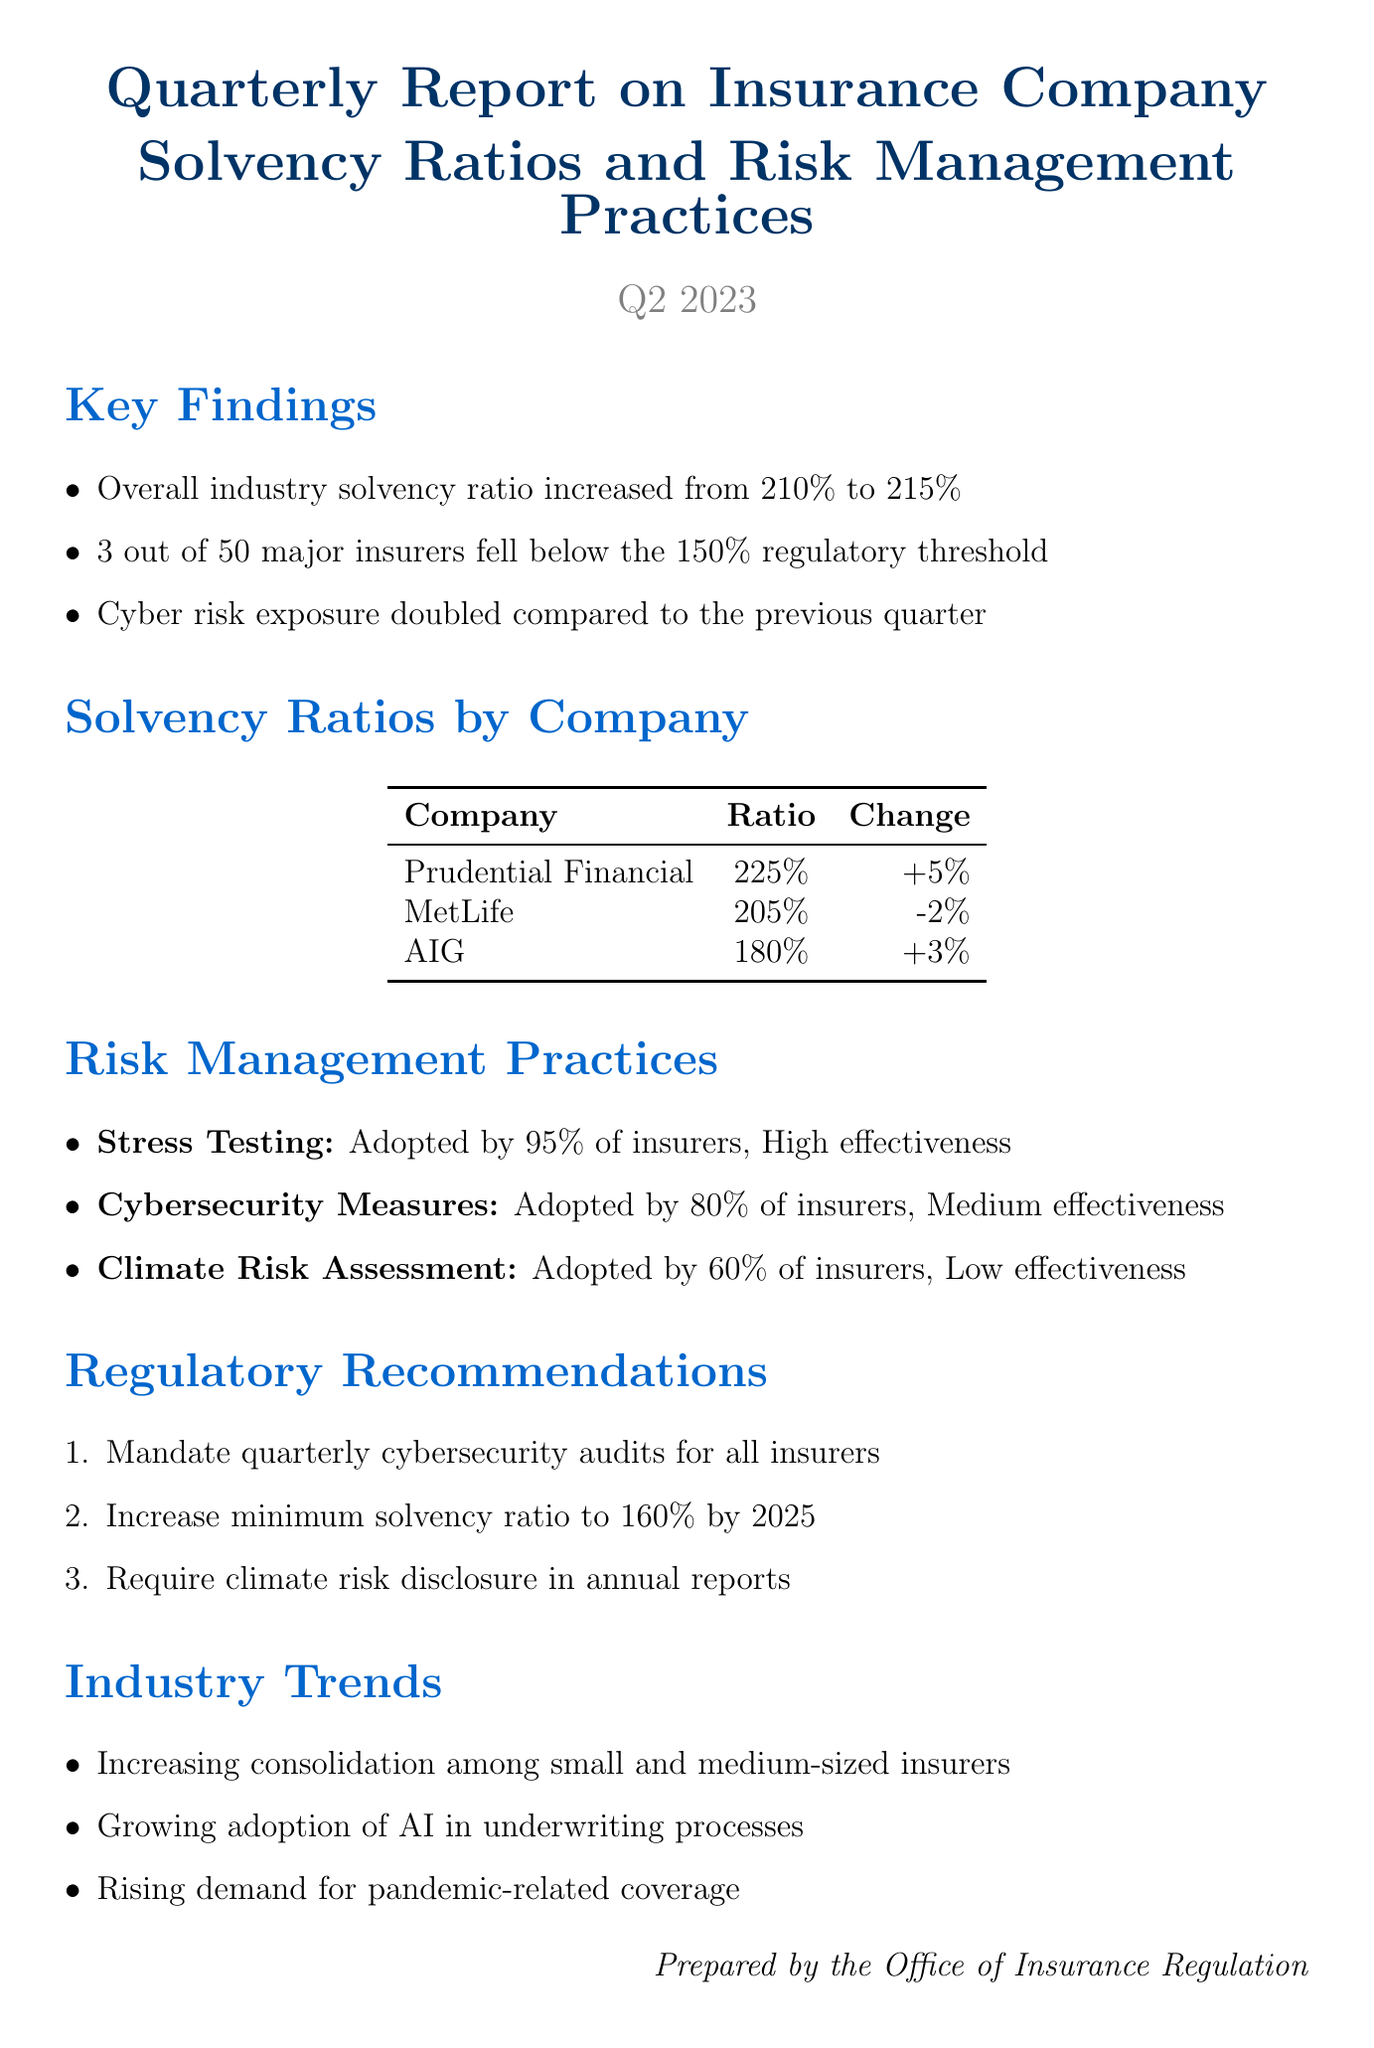What is the report title? The report title is found at the beginning of the document, which describes its main focus.
Answer: Quarterly Report on Insurance Company Solvency Ratios and Risk Management Practices What is the overall industry solvency ratio for Q2 2023? The overall industry solvency ratio is presented in the Key Findings section of the document.
Answer: 215% How many major insurers fell below the regulatory threshold? This is mentioned in the Key Findings section, highlighting the number of insurers in non-compliance.
Answer: 3 What is the cyber risk exposure change compared to the previous quarter? This detail is included in the Key Findings, indicating an increase.
Answer: Doubled What percentage of insurers adopted stress testing? This percentage is provided in the Risk Management Practices section, detailing a specific practice.
Answer: 95% Which company has the highest solvency ratio? The solvency ratios by company are listed in a table, making it easy to compare.
Answer: Prudential Financial What regulatory recommendation pertains to cybersecurity audits? This specific recommendation is found in the Regulatory Recommendations section of the document.
Answer: Mandate quarterly cybersecurity audits for all insurers What is the effectiveness level of climate risk assessment? This information is provided in the Risk Management Practices section, describing the effectiveness of a specific practice.
Answer: Low What trend is associated with small and medium-sized insurers? This trend is highlighted in the Industry Trends section, indicating a market behavior.
Answer: Increasing consolidation among small and medium-sized insurers 